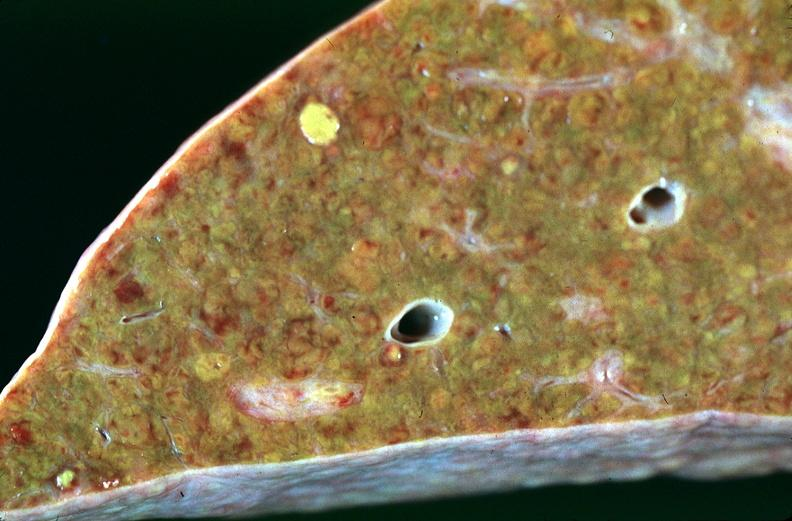how many antitrypsin does this image show liver, cirrhosis alpha-deficiency?
Answer the question using a single word or phrase. 1 